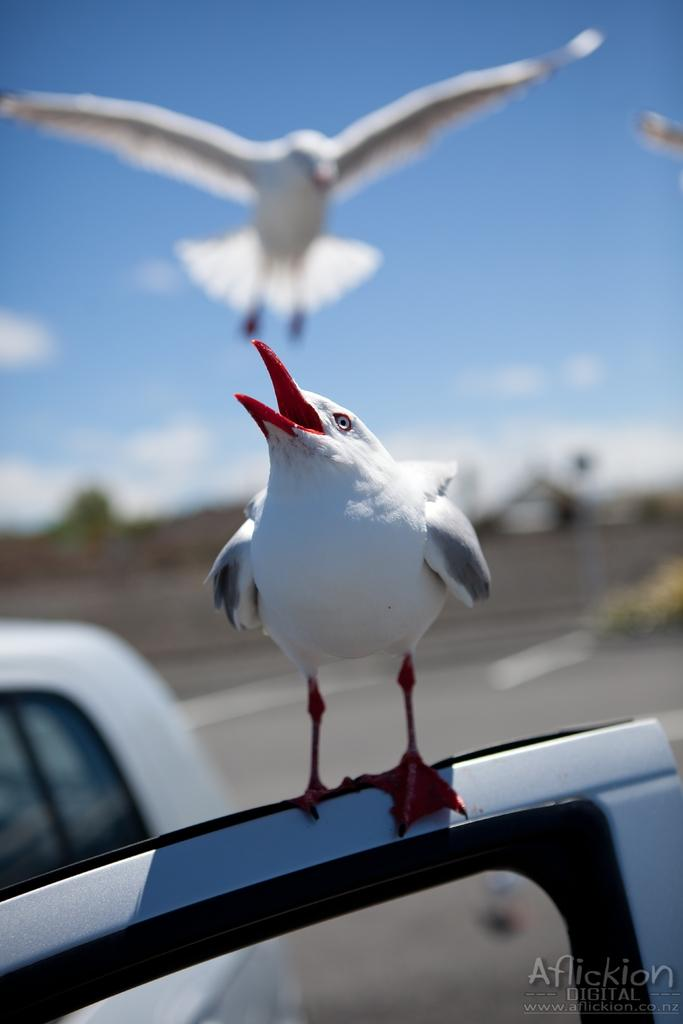What is the bird doing in the image? There is a bird standing on the opened door of a car. Are there any other birds in the image? Yes, there is another bird flying in the image. What can be seen in the background of the image? The sky is visible in the background. What is the condition of the sky in the image? Clouds are present in the sky. What type of board is the bird using to break the car's window in the image? There is no board or window-breaking activity present in the image. The bird is simply standing on the opened door of the car. 